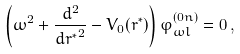<formula> <loc_0><loc_0><loc_500><loc_500>\left ( \omega ^ { 2 } + \frac { d ^ { 2 } } { { d r ^ { * } } ^ { 2 } } - V _ { 0 } ( r ^ { * } ) \right ) \varphi ^ { ( 0 n ) } _ { \omega l } = 0 \, ,</formula> 